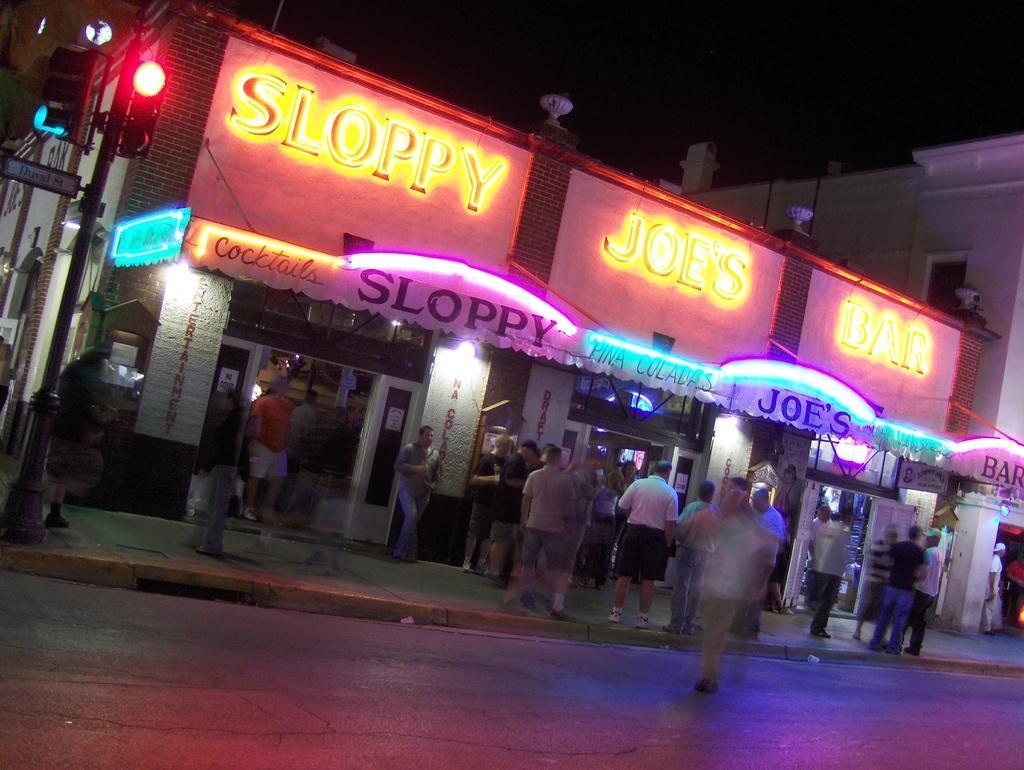Describe this image in one or two sentences. In the center of the image we can see a store and there are buildings. At the bottom there are people and we can see a road. On the left there are traffic lights. In the background there is sky. 